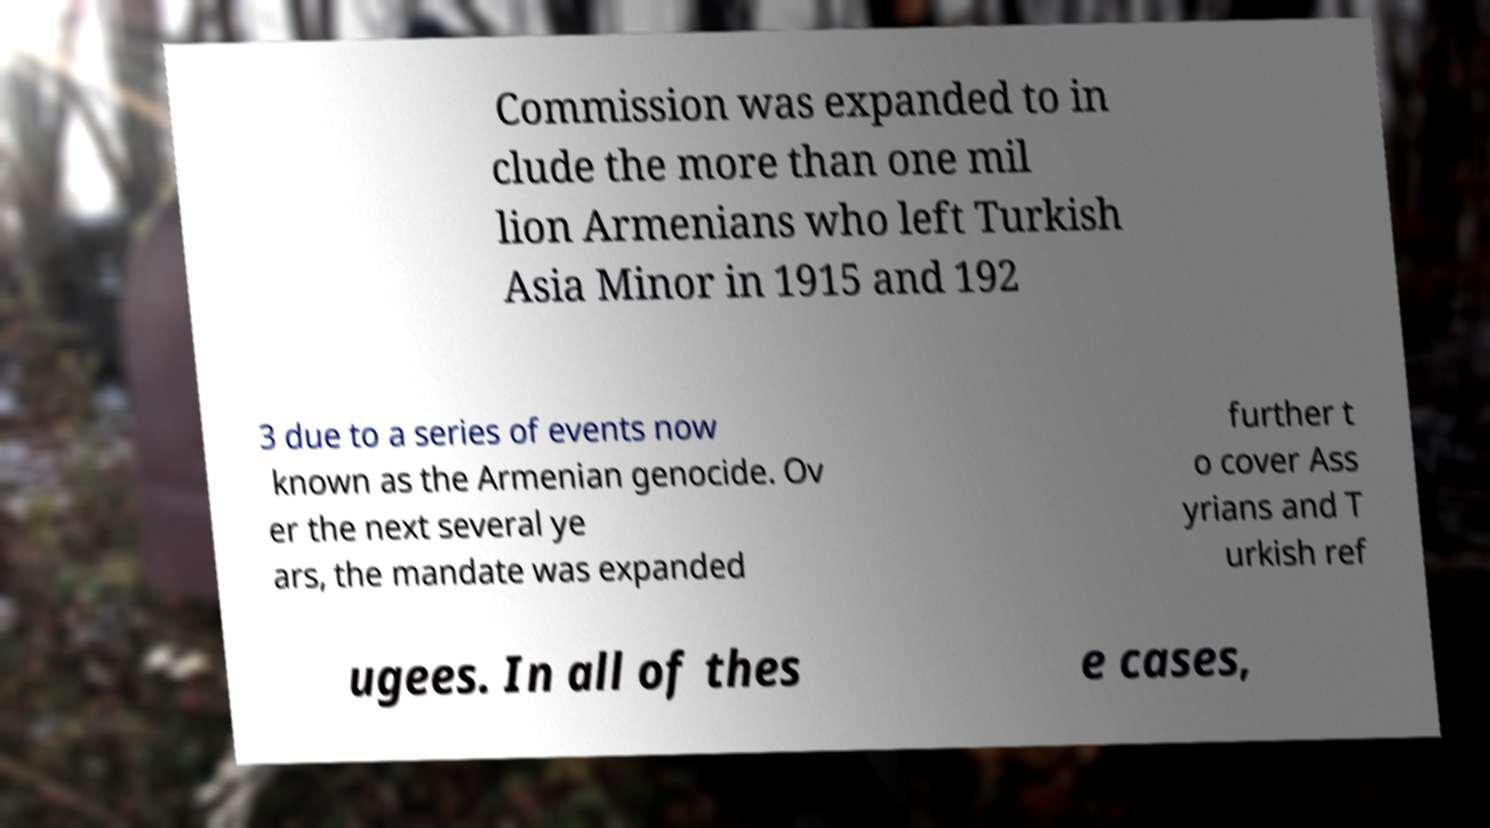For documentation purposes, I need the text within this image transcribed. Could you provide that? Commission was expanded to in clude the more than one mil lion Armenians who left Turkish Asia Minor in 1915 and 192 3 due to a series of events now known as the Armenian genocide. Ov er the next several ye ars, the mandate was expanded further t o cover Ass yrians and T urkish ref ugees. In all of thes e cases, 